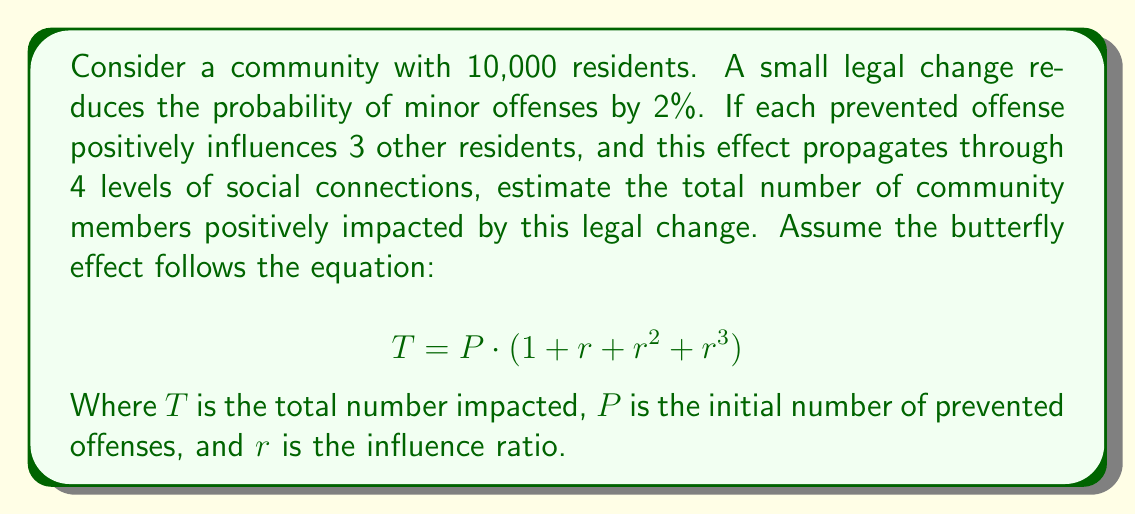Can you solve this math problem? 1. Calculate the number of prevented offenses:
   - 2% of 10,000 = $10000 \cdot 0.02 = 200$ prevented offenses

2. Set up the equation:
   $$T = P \cdot (1 + r + r^2 + r^3)$$
   Where $P = 200$ and $r = 3$

3. Substitute values:
   $$T = 200 \cdot (1 + 3 + 3^2 + 3^3)$$

4. Calculate powers:
   $$T = 200 \cdot (1 + 3 + 9 + 27)$$

5. Sum inside parentheses:
   $$T = 200 \cdot 40$$

6. Multiply:
   $$T = 8000$$

Therefore, the total number of community members positively impacted is 8,000.
Answer: 8,000 community members 